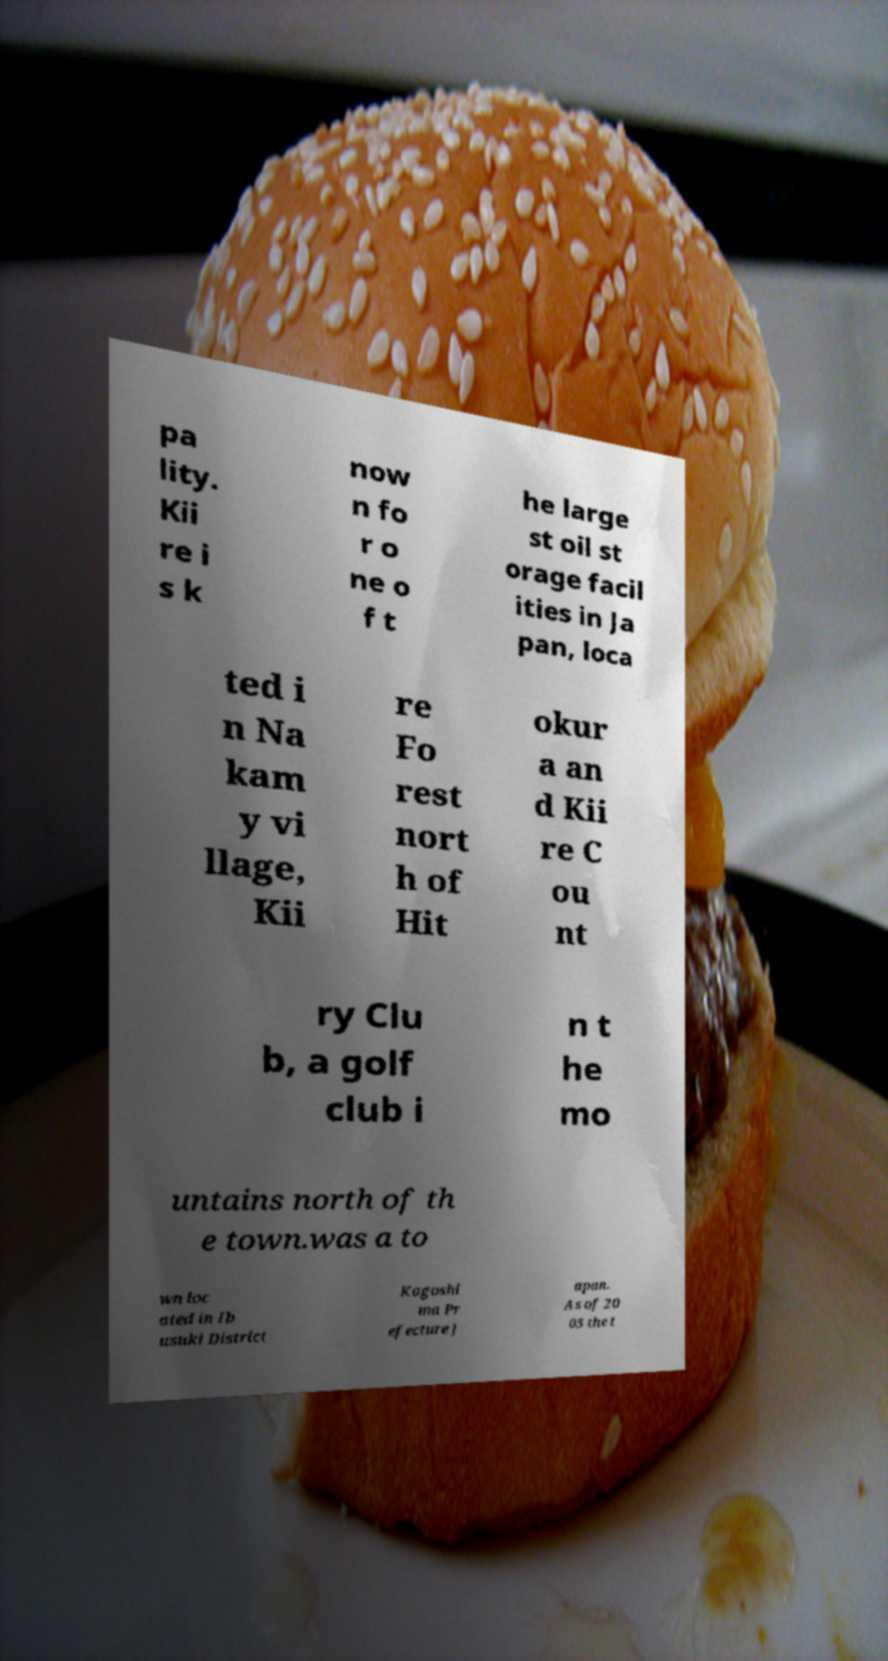What messages or text are displayed in this image? I need them in a readable, typed format. pa lity. Kii re i s k now n fo r o ne o f t he large st oil st orage facil ities in Ja pan, loca ted i n Na kam y vi llage, Kii re Fo rest nort h of Hit okur a an d Kii re C ou nt ry Clu b, a golf club i n t he mo untains north of th e town.was a to wn loc ated in Ib usuki District Kagoshi ma Pr efecture J apan. As of 20 03 the t 